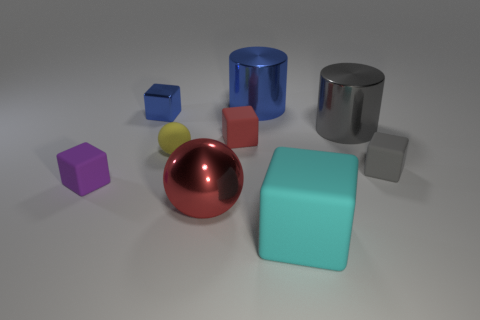What color is the metallic sphere?
Your answer should be very brief. Red. What size is the shiny object on the right side of the big shiny thing behind the metal cylinder right of the large rubber cube?
Ensure brevity in your answer.  Large. What number of other objects are there of the same color as the large sphere?
Your response must be concise. 1. The red thing that is the same size as the shiny block is what shape?
Offer a very short reply. Cube. How big is the blue metal thing behind the small blue metallic thing?
Your answer should be very brief. Large. There is a tiny block that is on the right side of the gray metal object; is it the same color as the big metal thing in front of the purple block?
Ensure brevity in your answer.  No. There is a sphere that is left of the red object that is on the left side of the small matte block behind the tiny yellow rubber sphere; what is its material?
Offer a terse response. Rubber. Are there any cyan spheres that have the same size as the yellow thing?
Offer a very short reply. No. There is a gray object that is the same size as the purple cube; what material is it?
Give a very brief answer. Rubber. The blue metallic thing that is left of the yellow thing has what shape?
Offer a very short reply. Cube. 